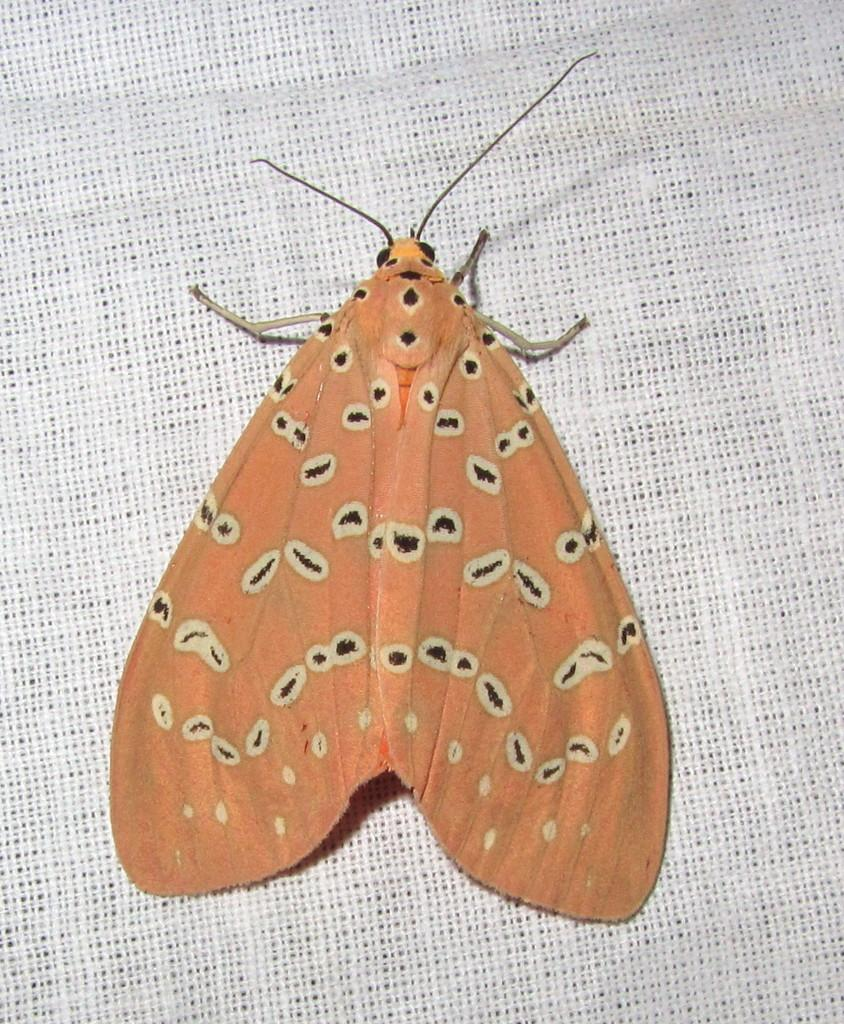What type of insect is present in the image? There is an orange color butterfly in the image. What is the butterfly resting on in the image? The butterfly is on a white color cloth. What color is the background of the image? The background of the image is white in color. How many books are visible in the image? There are no books present in the image; it features an orange color butterfly on a white color cloth with a white background. 